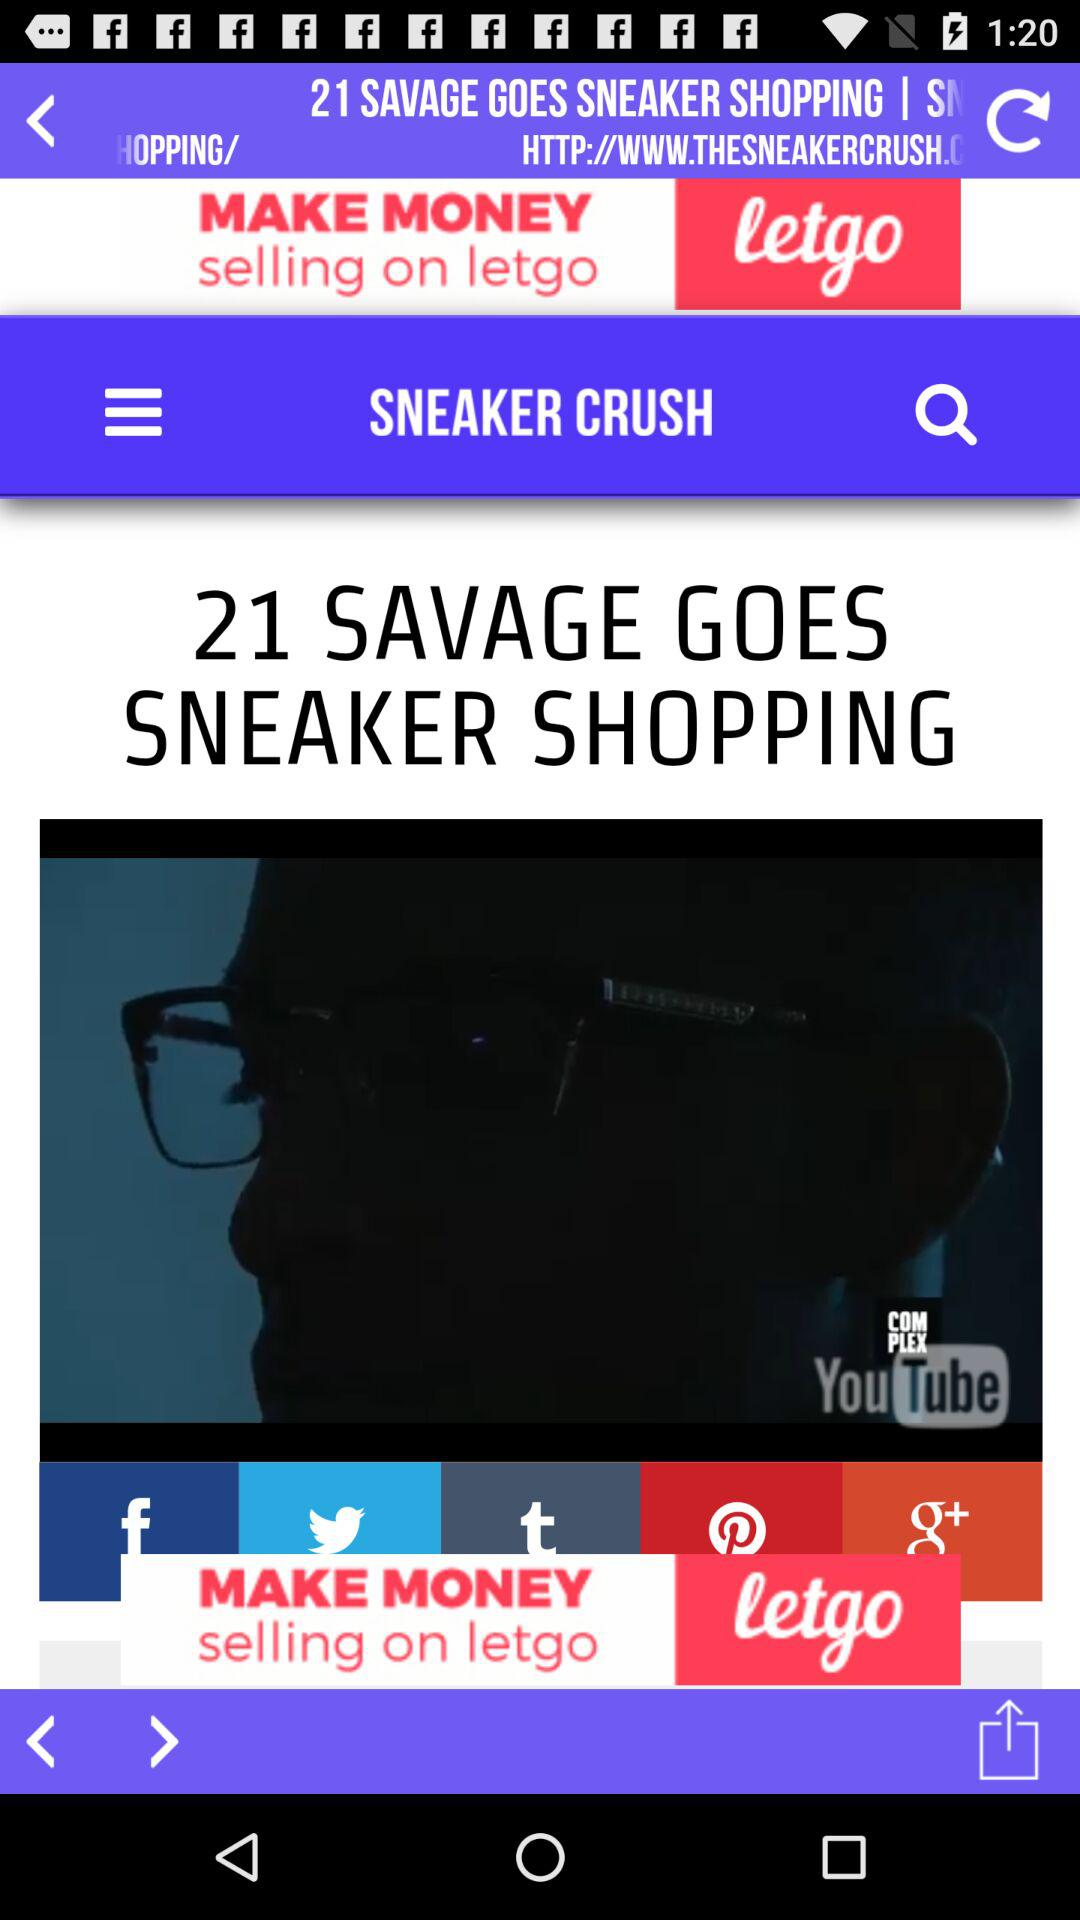What are the options to share? The options to share are "Facebook", "Twitter", "Tumblr", "Pinterest", "Google+". 